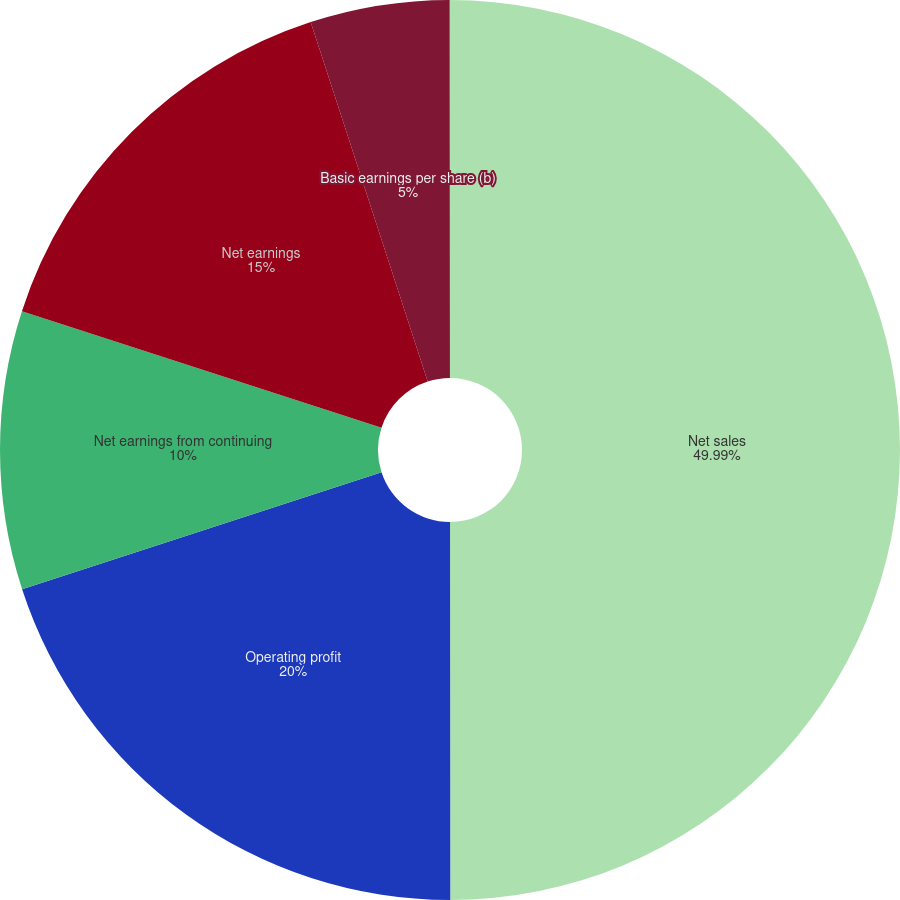<chart> <loc_0><loc_0><loc_500><loc_500><pie_chart><fcel>Net sales<fcel>Operating profit<fcel>Net earnings from continuing<fcel>Net earnings<fcel>Basic earnings per share (b)<fcel>Diluted earnings per share<nl><fcel>49.99%<fcel>20.0%<fcel>10.0%<fcel>15.0%<fcel>5.0%<fcel>0.01%<nl></chart> 